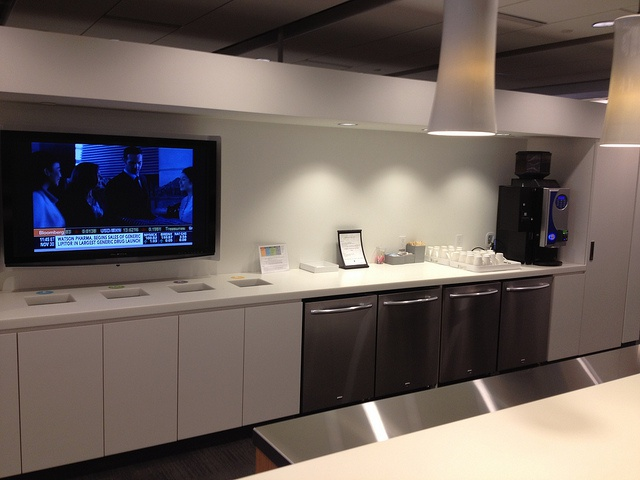Describe the objects in this image and their specific colors. I can see dining table in black, beige, gray, and tan tones, tv in black, navy, darkblue, and blue tones, refrigerator in black and gray tones, refrigerator in black, gray, and darkgray tones, and refrigerator in black and gray tones in this image. 